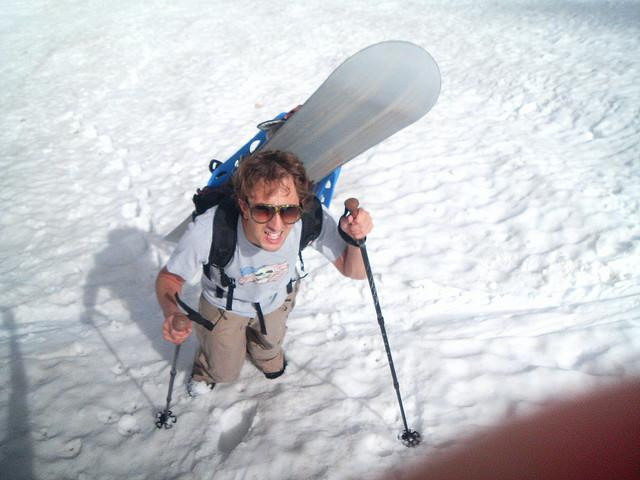What color is the bottom half of the snowboard which is carried up the hill by a man with ski poles? white 